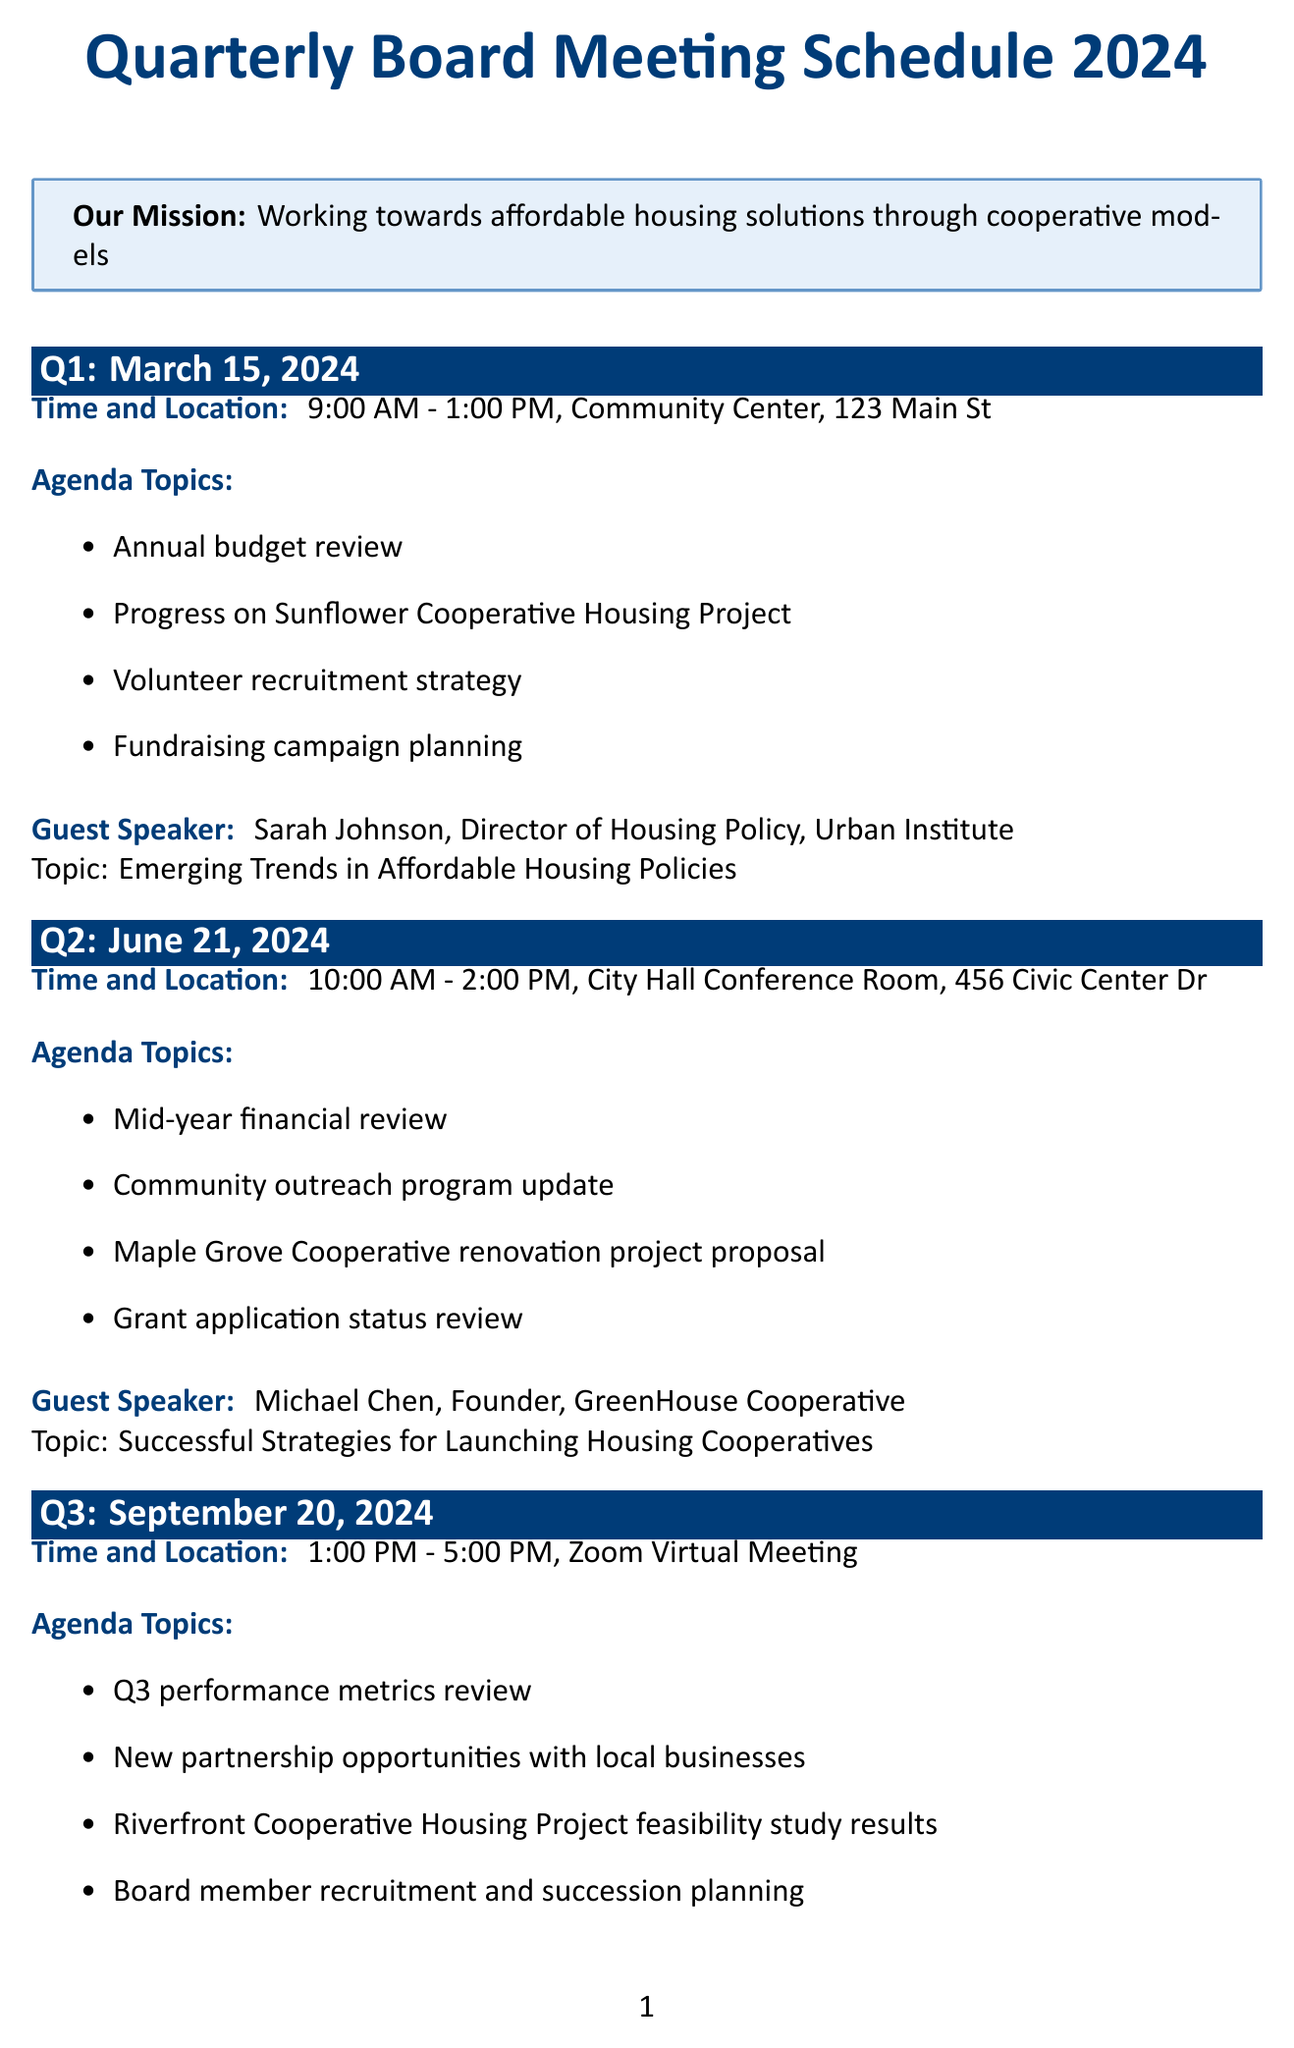What is the date of the Q1 meeting? The date of the Q1 meeting is specified in the schedule as March 15, 2024.
Answer: March 15, 2024 Who is the guest speaker for Q2? The guest speaker for Q2 is listed in the document as Michael Chen.
Answer: Michael Chen What time does the Q3 meeting start? The start time of the Q3 meeting is mentioned as 1:00 PM in the schedule.
Answer: 1:00 PM What topic will Sarah Johnson address? Sarah Johnson's topic is given as Emerging Trends in Affordable Housing Policies in the meeting details.
Answer: Emerging Trends in Affordable Housing Policies Which location hosts the Q4 meeting? The location for the Q4 meeting is specified as Oakwood Community Center, 789 Park Ave.
Answer: Oakwood Community Center, 789 Park Ave What is the main agenda topic for Q1 related to finances? The main agenda topic concerning finances in Q1 is stated as Annual budget review.
Answer: Annual budget review How many agenda topics are listed for Q3? The document lists four agenda topics for Q3, focusing on performance and partnerships.
Answer: Four Who is the title holder of the guest speaker for Q4? The title of the guest speaker for Q4 is mentioned as CEO, National Association of Housing Cooperatives.
Answer: CEO, National Association of Housing Cooperatives 